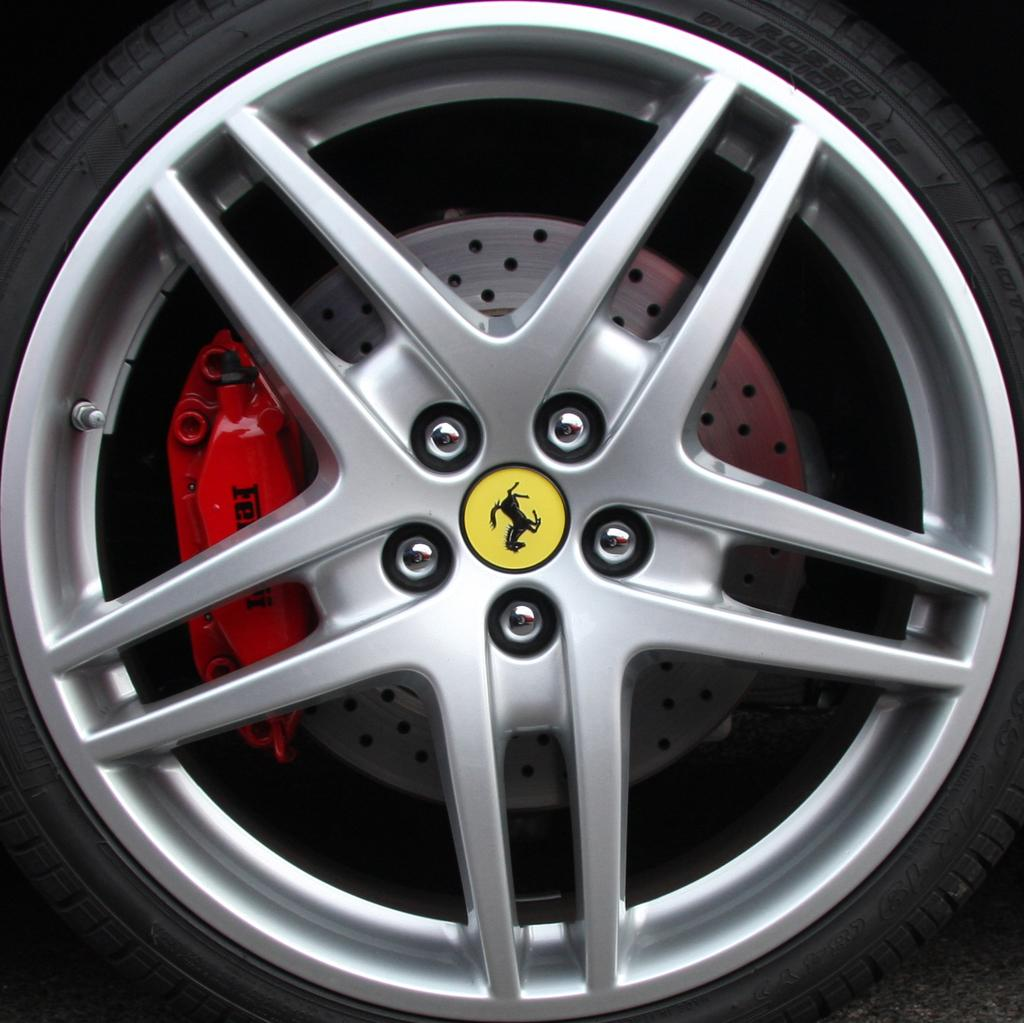What is the main subject of the image? The main subject of the image is a wheel of a vehicle. Can you describe the wheel in more detail? The wheel appears to be a part of a vehicle, possibly a car or truck. What is the context of the wheel in the image? The wheel is likely on the ground or attached to the vehicle, but the rest of the vehicle is not visible in the image. How many teeth can be seen on the wheel in the image? There are no teeth present on the wheel in the image, as it is a vehicle wheel and not a gear or other mechanism with teeth. 